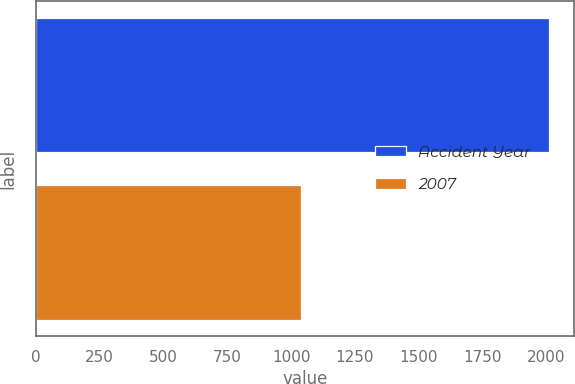Convert chart to OTSL. <chart><loc_0><loc_0><loc_500><loc_500><bar_chart><fcel>Accident Year<fcel>2007<nl><fcel>2009<fcel>1037<nl></chart> 